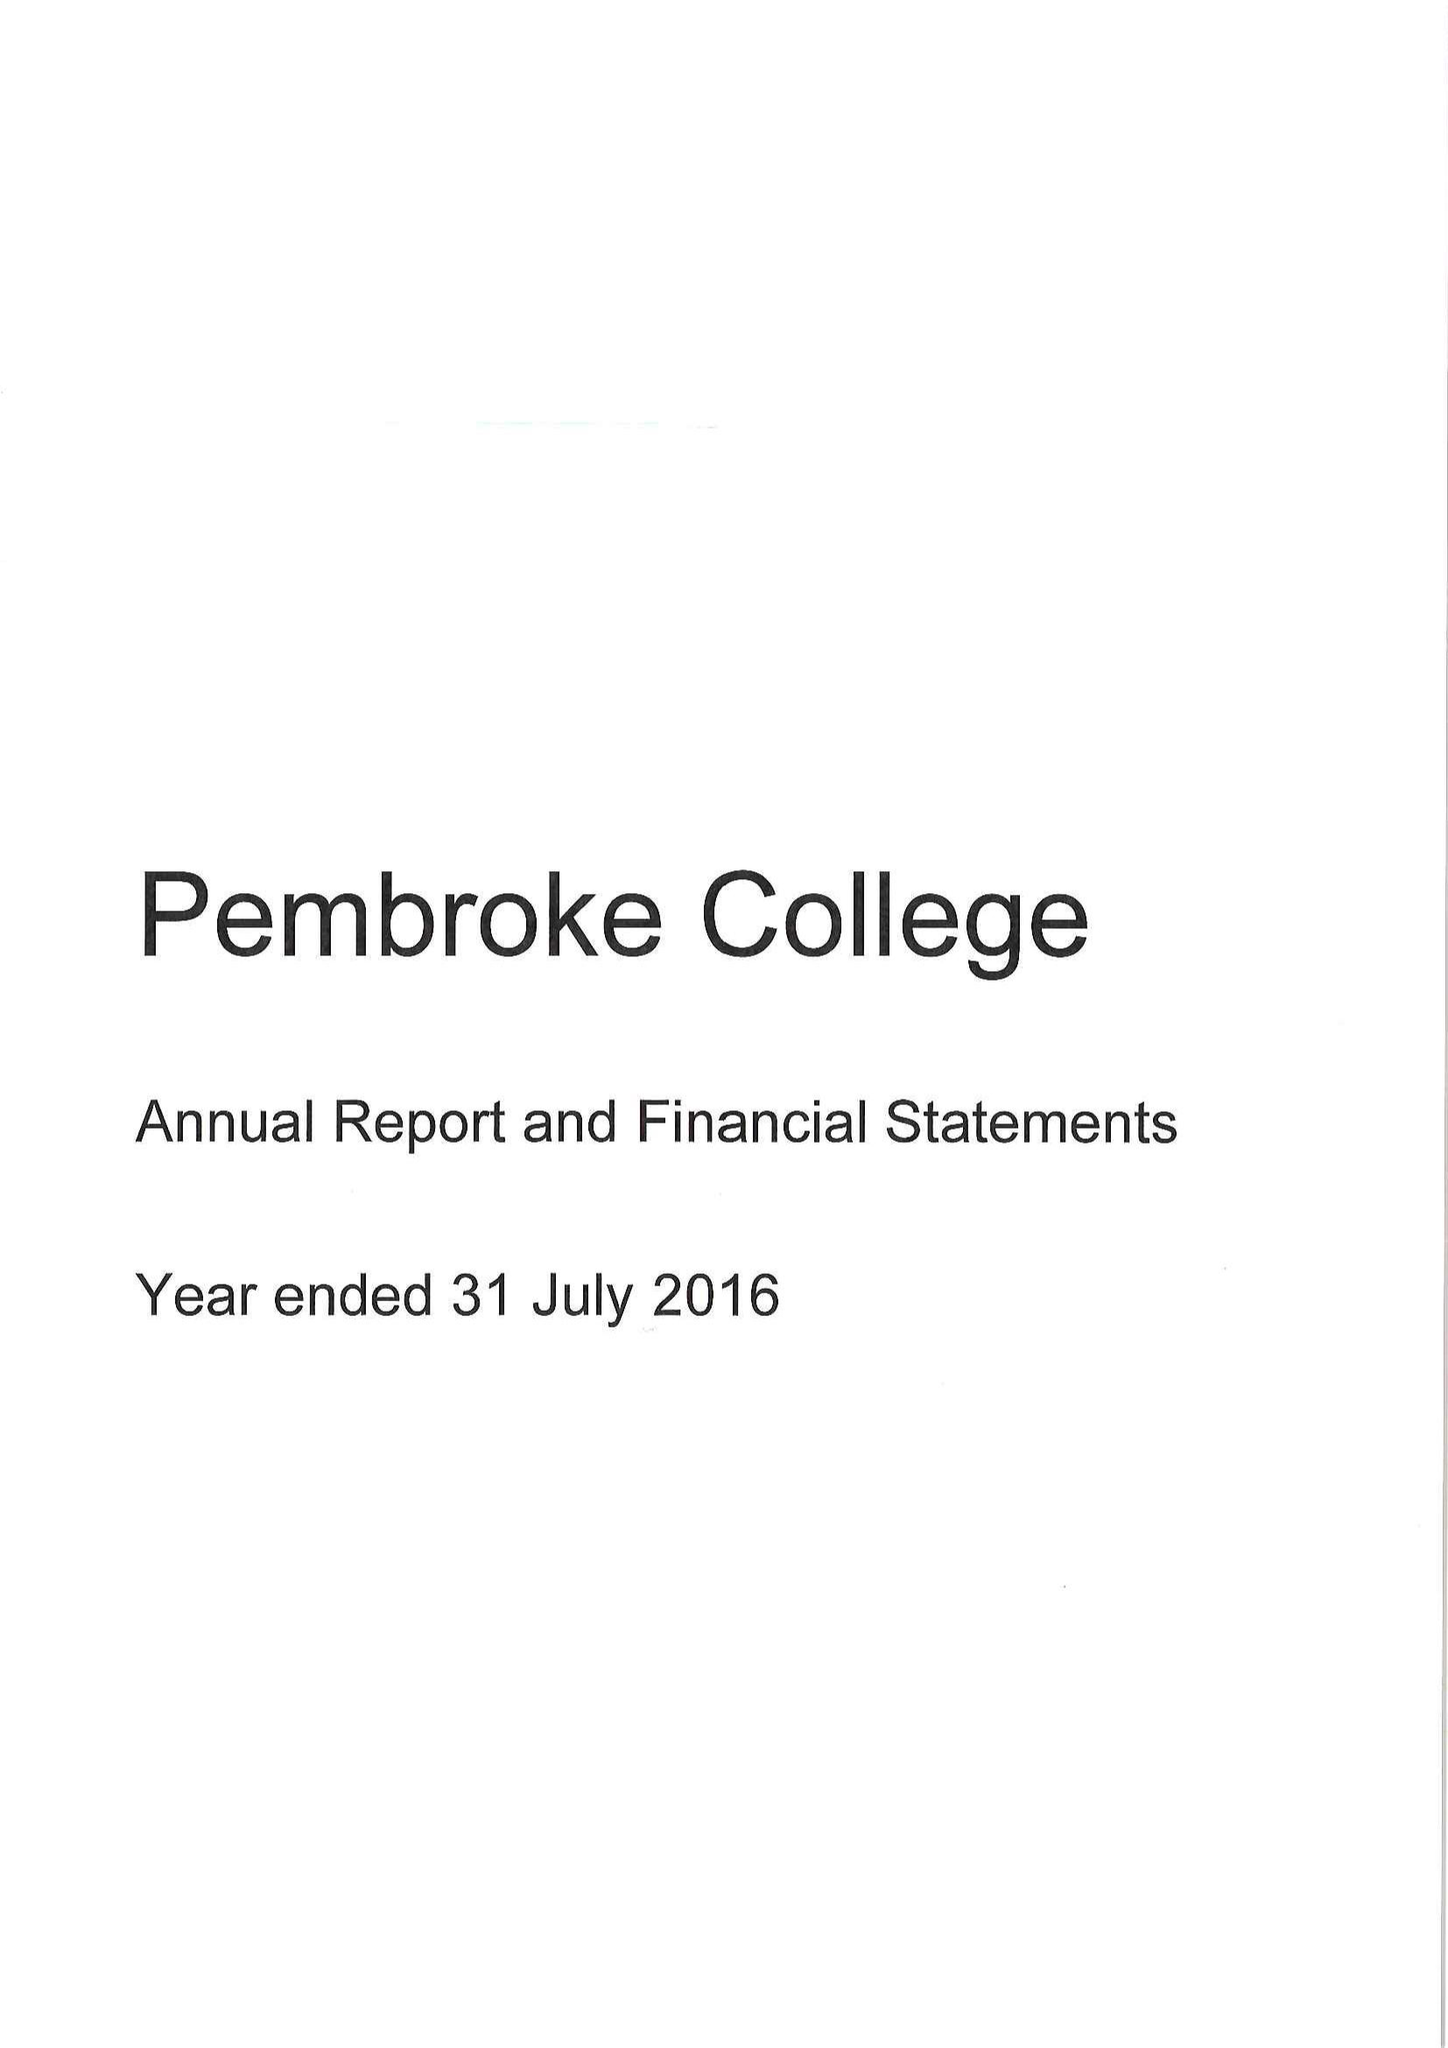What is the value for the address__post_town?
Answer the question using a single word or phrase. OXFORD 